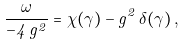Convert formula to latex. <formula><loc_0><loc_0><loc_500><loc_500>\frac { \omega } { - 4 \, g ^ { 2 } } = \chi ( \gamma ) - g ^ { 2 } \, \delta ( \gamma ) \, ,</formula> 